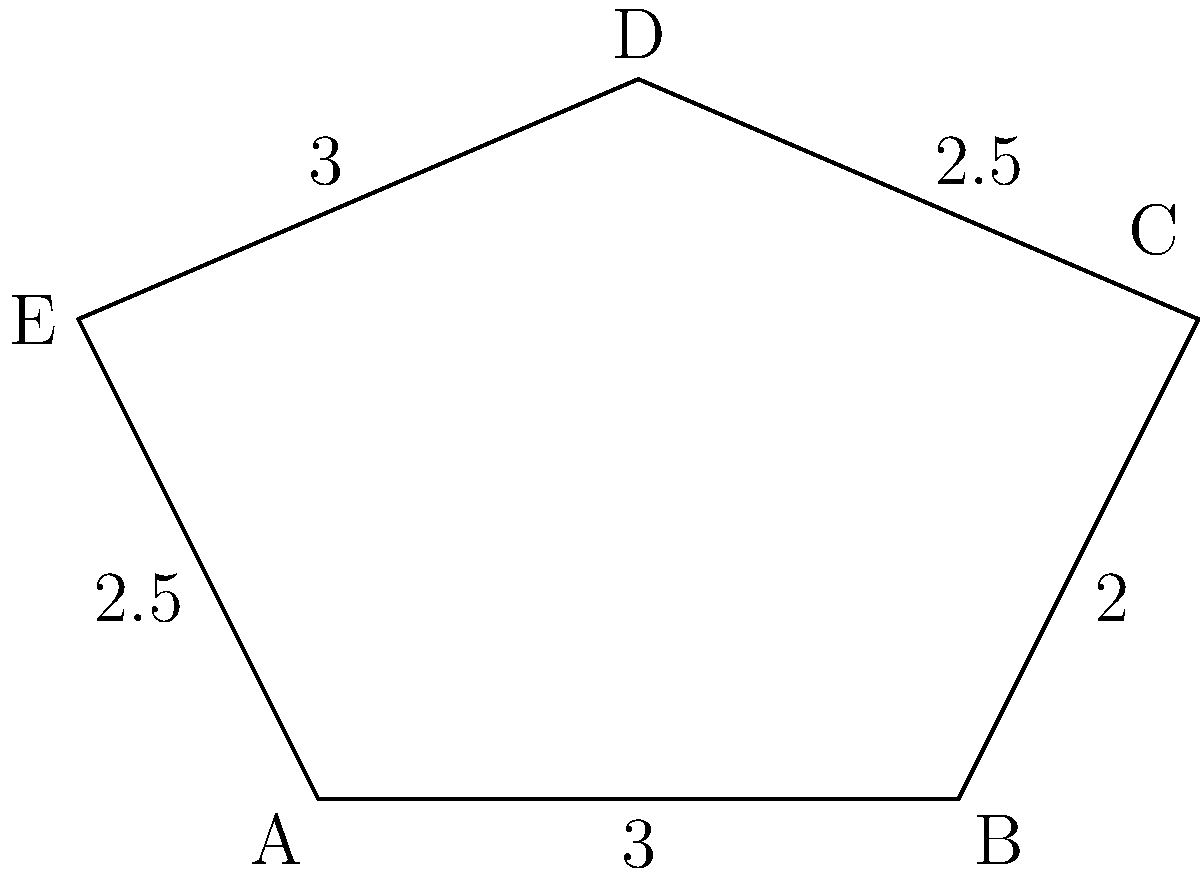In Mia's Magic Playground, you notice a pentagonal ice cream stand. The lengths of its sides are 3, 2, 2.5, 3, and 2.5 units, in that order. What is the perimeter of this delicious-looking stand? Let's approach this step-by-step:

1) The perimeter of a polygon is the sum of the lengths of all its sides.

2) We are given the lengths of all five sides of the pentagonal ice cream stand:
   - Side 1: 3 units
   - Side 2: 2 units
   - Side 3: 2.5 units
   - Side 4: 3 units
   - Side 5: 2.5 units

3) To find the perimeter, we simply need to add these lengths:

   $$\text{Perimeter} = 3 + 2 + 2.5 + 3 + 2.5$$

4) Let's perform the addition:

   $$\text{Perimeter} = 13 \text{ units}$$

Therefore, the perimeter of the pentagonal ice cream stand is 13 units.
Answer: 13 units 